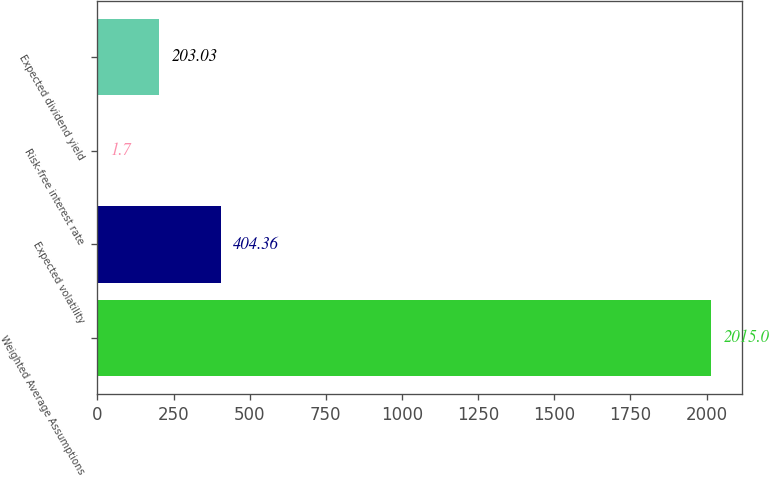<chart> <loc_0><loc_0><loc_500><loc_500><bar_chart><fcel>Weighted Average Assumptions<fcel>Expected volatility<fcel>Risk-free interest rate<fcel>Expected dividend yield<nl><fcel>2015<fcel>404.36<fcel>1.7<fcel>203.03<nl></chart> 